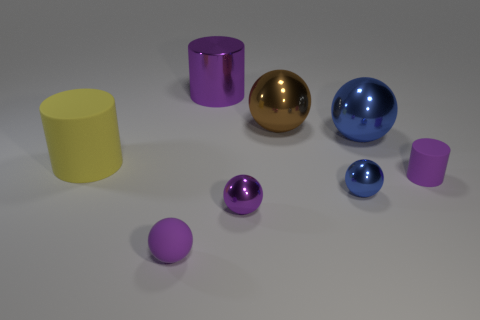Is the size of the blue ball that is in front of the yellow rubber cylinder the same as the cylinder that is on the right side of the brown metal object?
Keep it short and to the point. Yes. Are there the same number of blue things behind the large metallic cylinder and yellow rubber cylinders to the left of the small cylinder?
Provide a succinct answer. No. There is a brown ball; does it have the same size as the rubber cylinder right of the yellow matte cylinder?
Give a very brief answer. No. There is a tiny purple thing on the right side of the brown shiny thing that is to the right of the large yellow object; what is it made of?
Your answer should be compact. Rubber. Is the number of small purple balls that are on the right side of the large purple cylinder the same as the number of blue shiny things?
Make the answer very short. No. There is a matte object that is to the left of the small cylinder and in front of the big yellow cylinder; what size is it?
Your response must be concise. Small. There is a large metallic object that is right of the tiny metal thing behind the small purple metallic thing; what color is it?
Your answer should be very brief. Blue. What number of green things are big rubber objects or blocks?
Ensure brevity in your answer.  0. What color is the metallic object that is on the left side of the brown thing and in front of the brown metallic object?
Keep it short and to the point. Purple. What number of small things are either blue metallic balls or spheres?
Your answer should be compact. 3. 